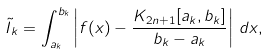<formula> <loc_0><loc_0><loc_500><loc_500>\tilde { I } _ { k } = \int _ { a _ { k } } ^ { b _ { k } } \left | f ( x ) - \frac { K _ { 2 n + 1 } [ a _ { k } , b _ { k } ] } { b _ { k } - a _ { k } } \right | \, d x ,</formula> 